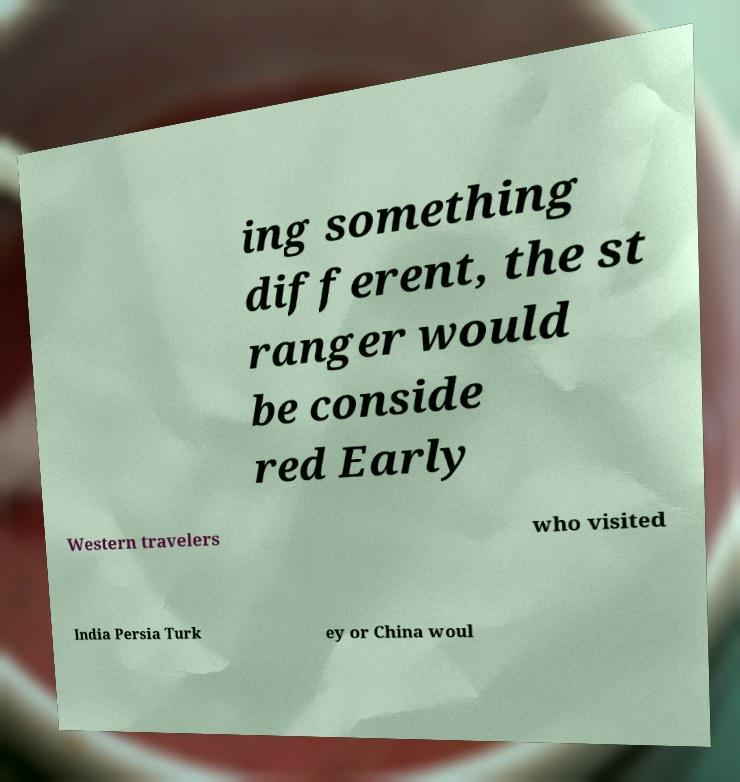Could you extract and type out the text from this image? ing something different, the st ranger would be conside red Early Western travelers who visited India Persia Turk ey or China woul 